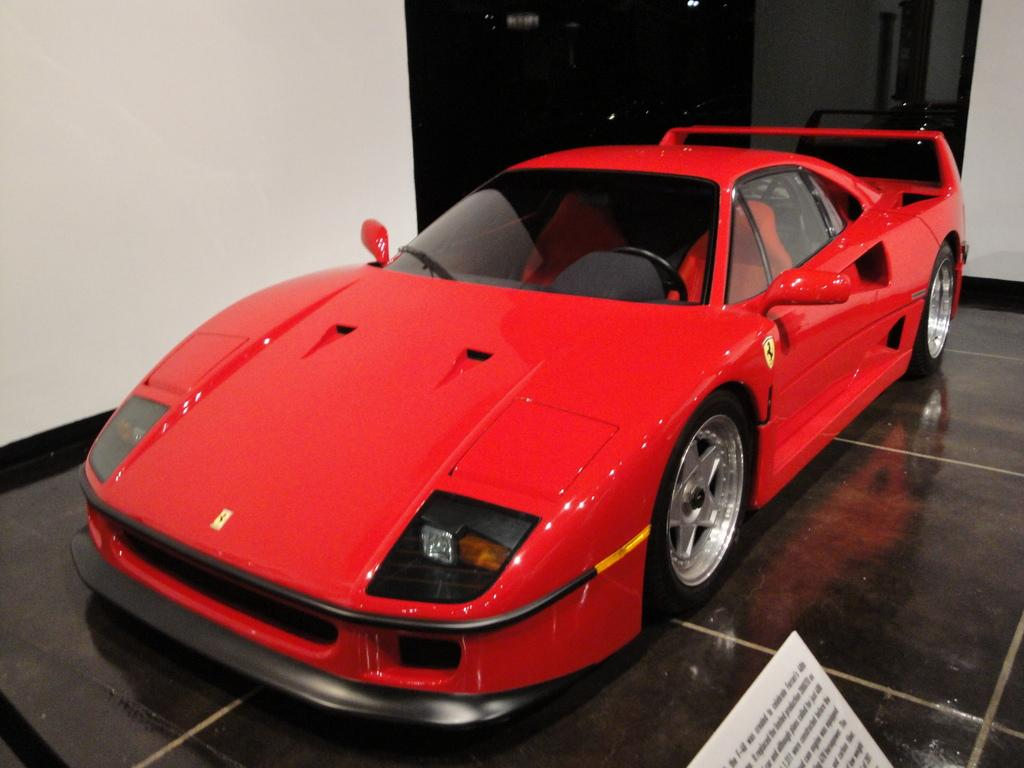What is the main subject of the image? The main subject of the image is a car. What else can be seen in the image besides the car? There is a wall in the image. Can you see any fangs on the car in the image? There are no fangs present on the car in the image. 